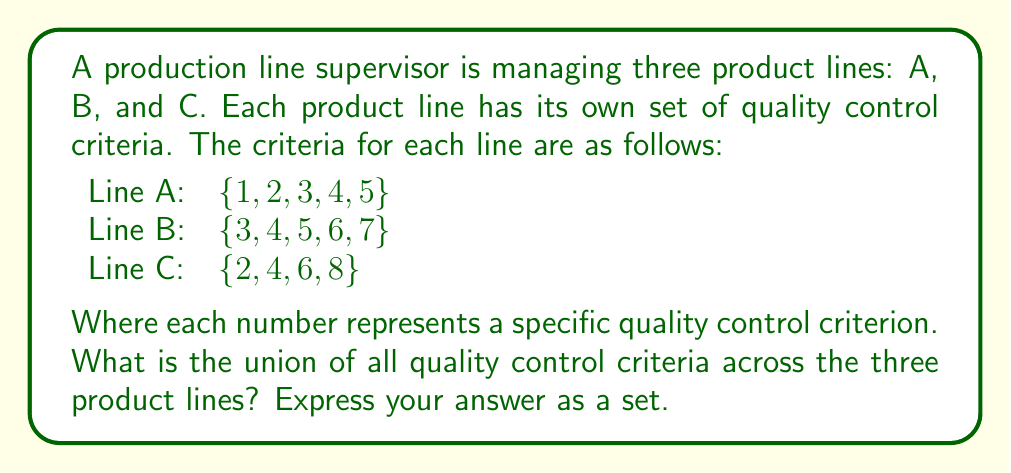Solve this math problem. To find the union of quality control criteria across multiple product lines, we need to combine all unique elements from each set. Let's approach this step-by-step:

1. First, let's define our sets:
   Set A = $\{1, 2, 3, 4, 5\}$
   Set B = $\{3, 4, 5, 6, 7\}$
   Set C = $\{2, 4, 6, 8\}$

2. The union of these sets is denoted as $A \cup B \cup C$, which includes all elements that appear in at least one of the sets, without repetition.

3. Let's start with the union of A and B:
   $A \cup B = \{1, 2, 3, 4, 5, 6, 7\}$

4. Now, let's add the unique elements from C to this union:
   $(A \cup B) \cup C = \{1, 2, 3, 4, 5, 6, 7\} \cup \{2, 4, 6, 8\}$

5. The only new element from C that isn't already in $A \cup B$ is 8.

6. Therefore, the final union of all three sets is:
   $A \cup B \cup C = \{1, 2, 3, 4, 5, 6, 7, 8\}$

This union represents all unique quality control criteria across the three product lines.
Answer: $\{1, 2, 3, 4, 5, 6, 7, 8\}$ 